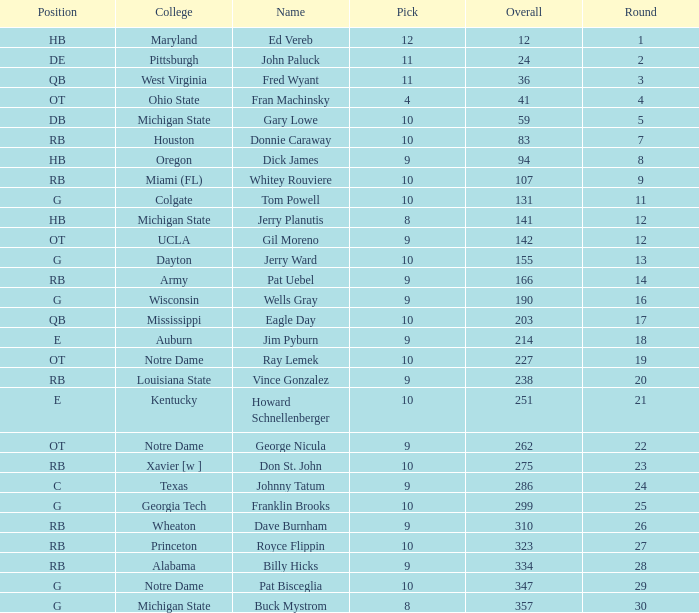What is the sum of rounds that has a pick of 9 and is named jim pyburn? 18.0. 